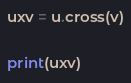Convert code to text. <code><loc_0><loc_0><loc_500><loc_500><_Python_>uxv = u.cross(v)

print(uxv)
</code> 